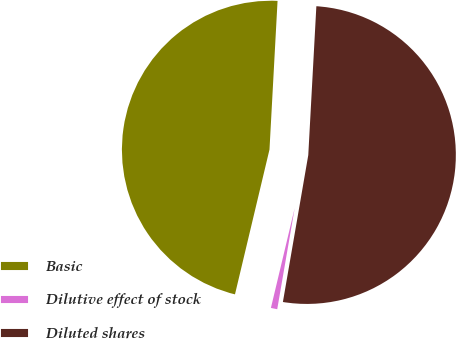Convert chart to OTSL. <chart><loc_0><loc_0><loc_500><loc_500><pie_chart><fcel>Basic<fcel>Dilutive effect of stock<fcel>Diluted shares<nl><fcel>47.14%<fcel>1.0%<fcel>51.86%<nl></chart> 